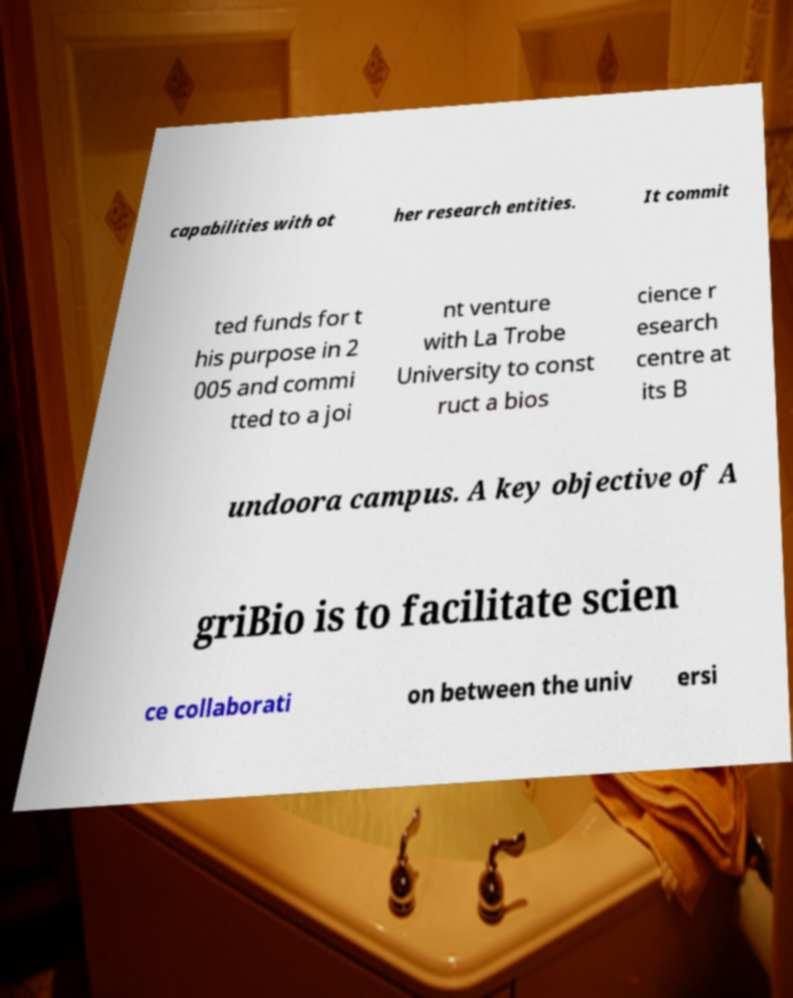Can you accurately transcribe the text from the provided image for me? capabilities with ot her research entities. It commit ted funds for t his purpose in 2 005 and commi tted to a joi nt venture with La Trobe University to const ruct a bios cience r esearch centre at its B undoora campus. A key objective of A griBio is to facilitate scien ce collaborati on between the univ ersi 